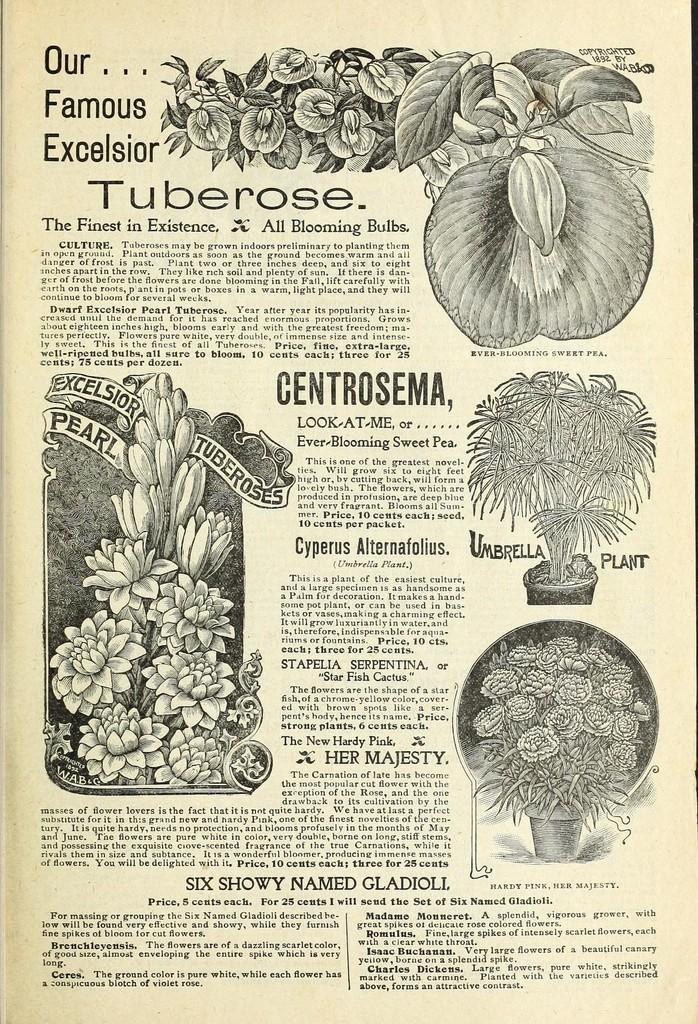How would you summarize this image in a sentence or two? In this picture we can see a magazine paper in the image. In the front we can see some plants and rose pot. On the top we can see "Tuberose" is written. 